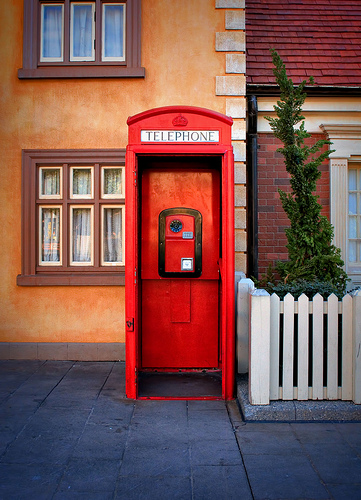<image>
Is there a fence next to the phonebox? Yes. The fence is positioned adjacent to the phonebox, located nearby in the same general area. 